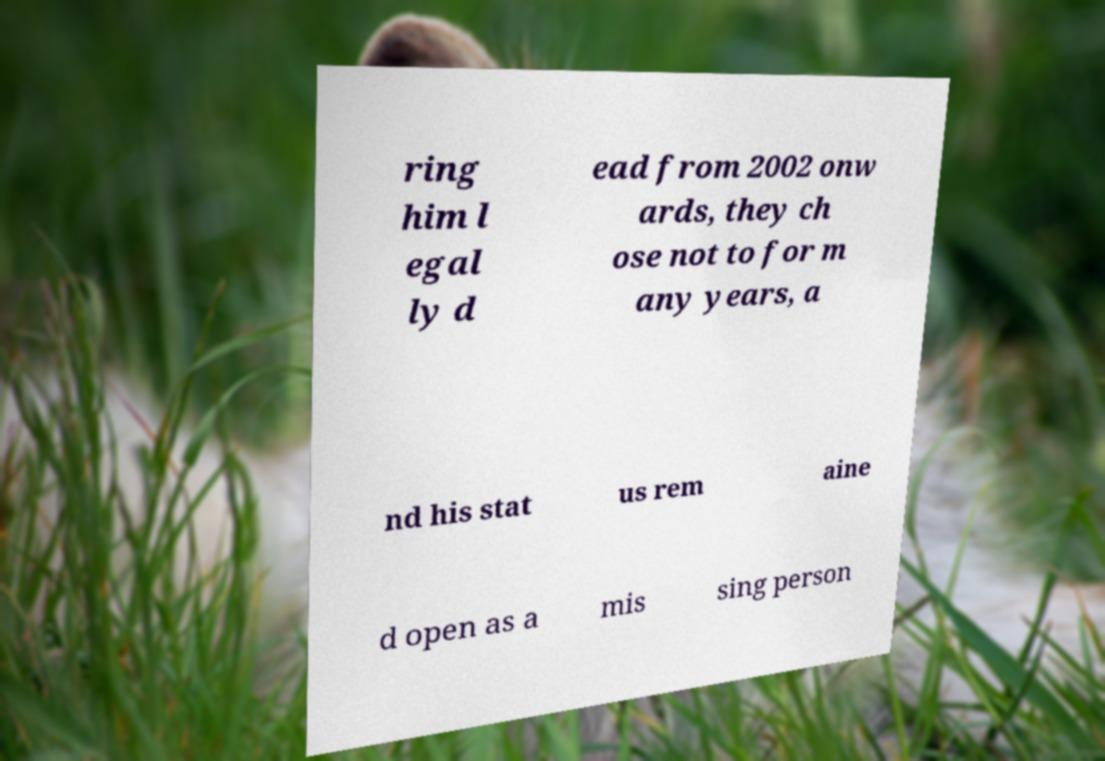Please identify and transcribe the text found in this image. ring him l egal ly d ead from 2002 onw ards, they ch ose not to for m any years, a nd his stat us rem aine d open as a mis sing person 